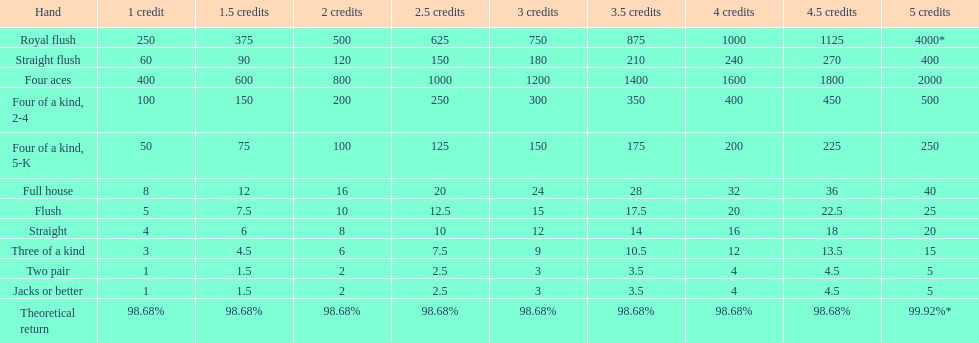Which is a higher standing hand: a straight or a flush? Flush. 